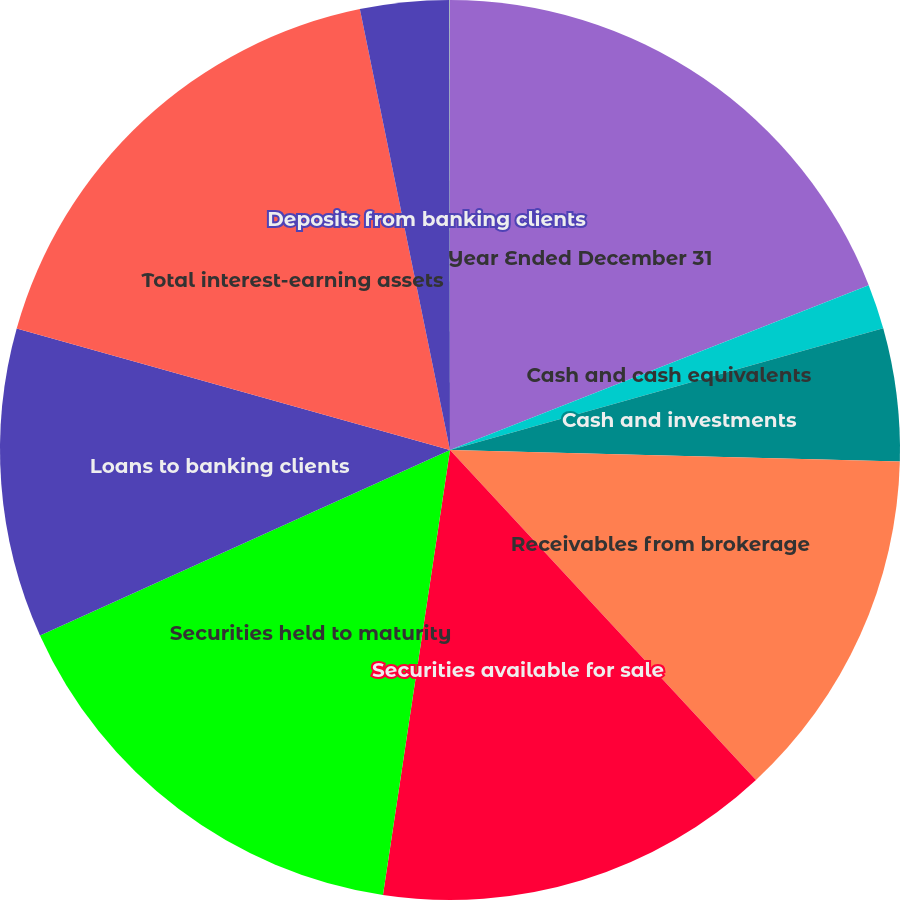<chart> <loc_0><loc_0><loc_500><loc_500><pie_chart><fcel>Year Ended December 31<fcel>Cash and cash equivalents<fcel>Cash and investments<fcel>Receivables from brokerage<fcel>Securities available for sale<fcel>Securities held to maturity<fcel>Loans to banking clients<fcel>Total interest-earning assets<fcel>Deposits from banking clients<fcel>Payables to brokerage clients<nl><fcel>19.03%<fcel>1.61%<fcel>4.77%<fcel>12.69%<fcel>14.28%<fcel>15.86%<fcel>11.11%<fcel>17.44%<fcel>3.19%<fcel>0.02%<nl></chart> 